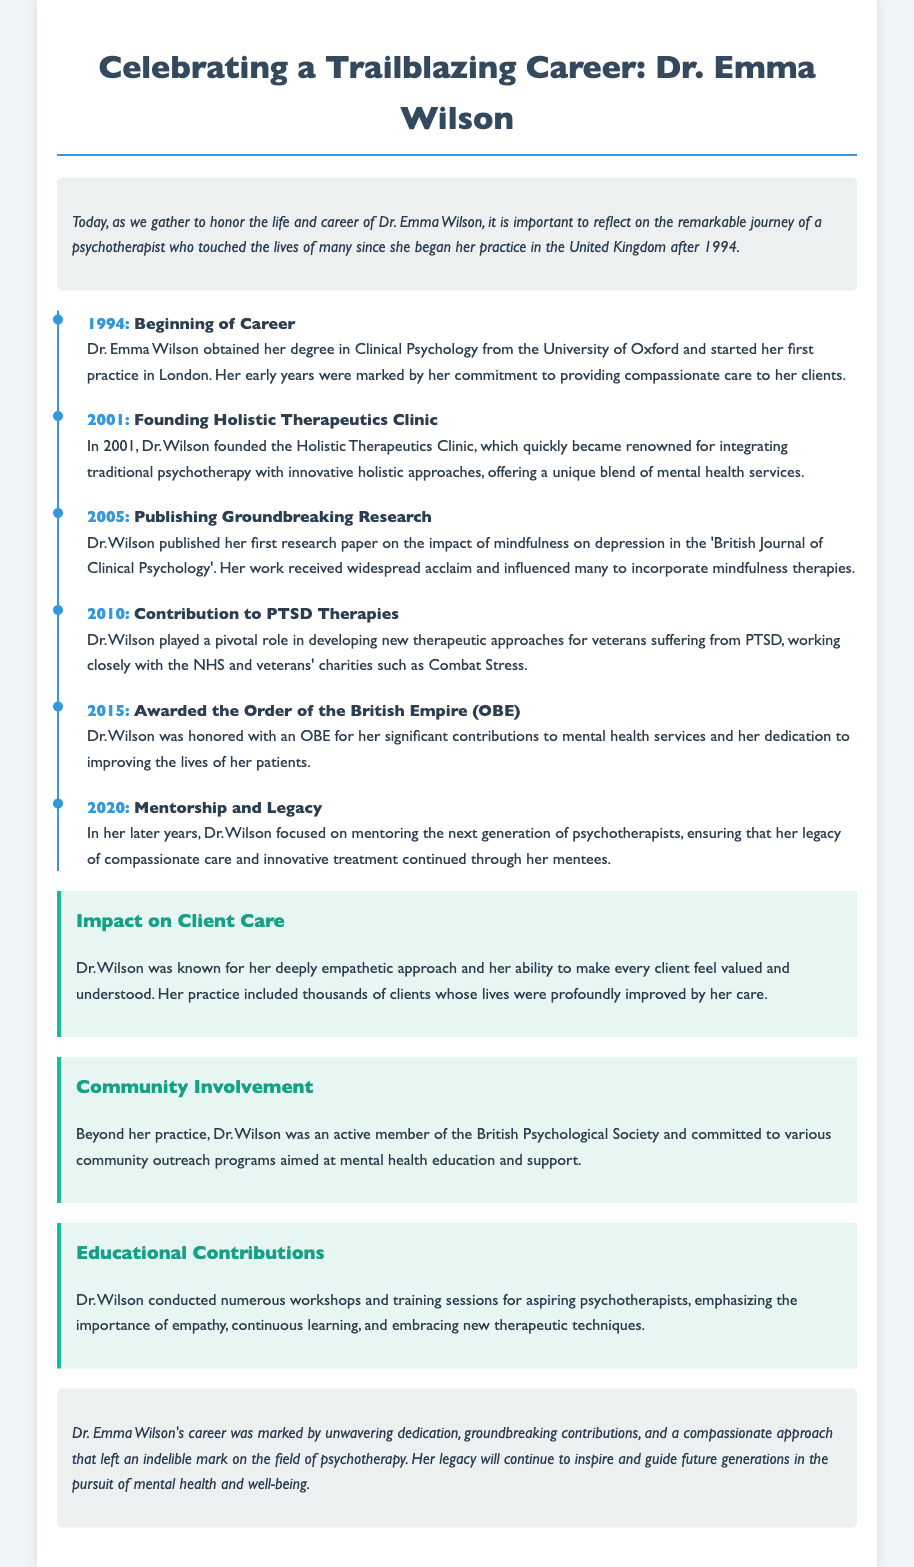What year did Dr. Emma Wilson start her practice? The document states that Dr. Wilson began her practice in 1994.
Answer: 1994 What is the name of the clinic founded by Dr. Wilson? The document mentions that Dr. Wilson founded the Holistic Therapeutics Clinic.
Answer: Holistic Therapeutics Clinic What recognition did Dr. Wilson receive in 2015? The document notes that she was awarded the Order of the British Empire (OBE) in 2015.
Answer: OBE In what year did Dr. Wilson publish her first research paper? The text indicates that Dr. Wilson published her first research paper in 2005.
Answer: 2005 What key therapeutic approach did Dr. Wilson focus on in 2010? According to the document, she contributed to developing new therapeutic approaches for PTSD.
Answer: PTSD How did Dr. Wilson impact client care? The document highlights her deeply empathetic approach and ability to make clients feel valued.
Answer: Empathy What was Dr. Wilson's focus in her later years? The document states that she focused on mentoring the next generation of psychotherapists.
Answer: Mentorship Which organization was Dr. Wilson actively involved with? The document mentions her active membership with the British Psychological Society.
Answer: British Psychological Society What quality is emphasized in Dr. Wilson's educational contributions? The text indicates the importance of empathy in her workshops and training sessions.
Answer: Empathy 